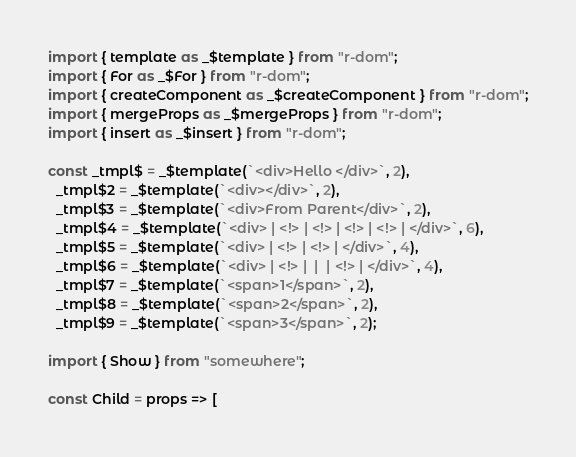<code> <loc_0><loc_0><loc_500><loc_500><_JavaScript_>import { template as _$template } from "r-dom";
import { For as _$For } from "r-dom";
import { createComponent as _$createComponent } from "r-dom";
import { mergeProps as _$mergeProps } from "r-dom";
import { insert as _$insert } from "r-dom";

const _tmpl$ = _$template(`<div>Hello </div>`, 2),
  _tmpl$2 = _$template(`<div></div>`, 2),
  _tmpl$3 = _$template(`<div>From Parent</div>`, 2),
  _tmpl$4 = _$template(`<div> | <!> | <!> | <!> | <!> | </div>`, 6),
  _tmpl$5 = _$template(`<div> | <!> | <!> | </div>`, 4),
  _tmpl$6 = _$template(`<div> | <!> |  |  | <!> | </div>`, 4),
  _tmpl$7 = _$template(`<span>1</span>`, 2),
  _tmpl$8 = _$template(`<span>2</span>`, 2),
  _tmpl$9 = _$template(`<span>3</span>`, 2);

import { Show } from "somewhere";

const Child = props => [</code> 